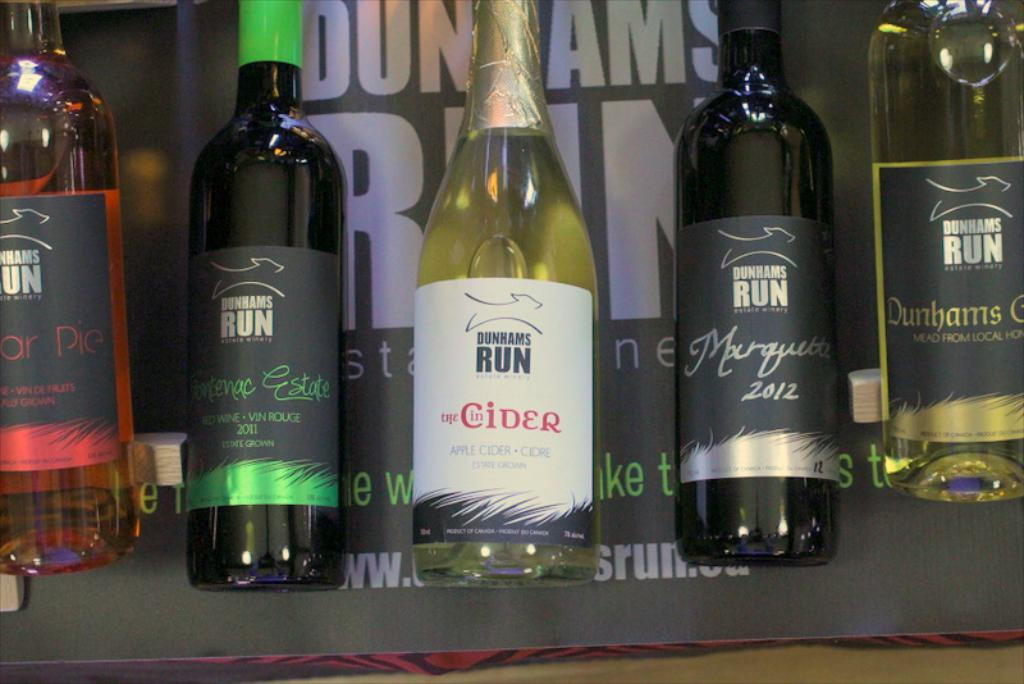Provide a one-sentence caption for the provided image. The image displays an array of Dunhams Run's alcoholic products, featuring a diverse selection from apple cider to vintage wines such as Frontenac Estate 2011 and Marquette 2012, highlighting the brand's robust variety. 